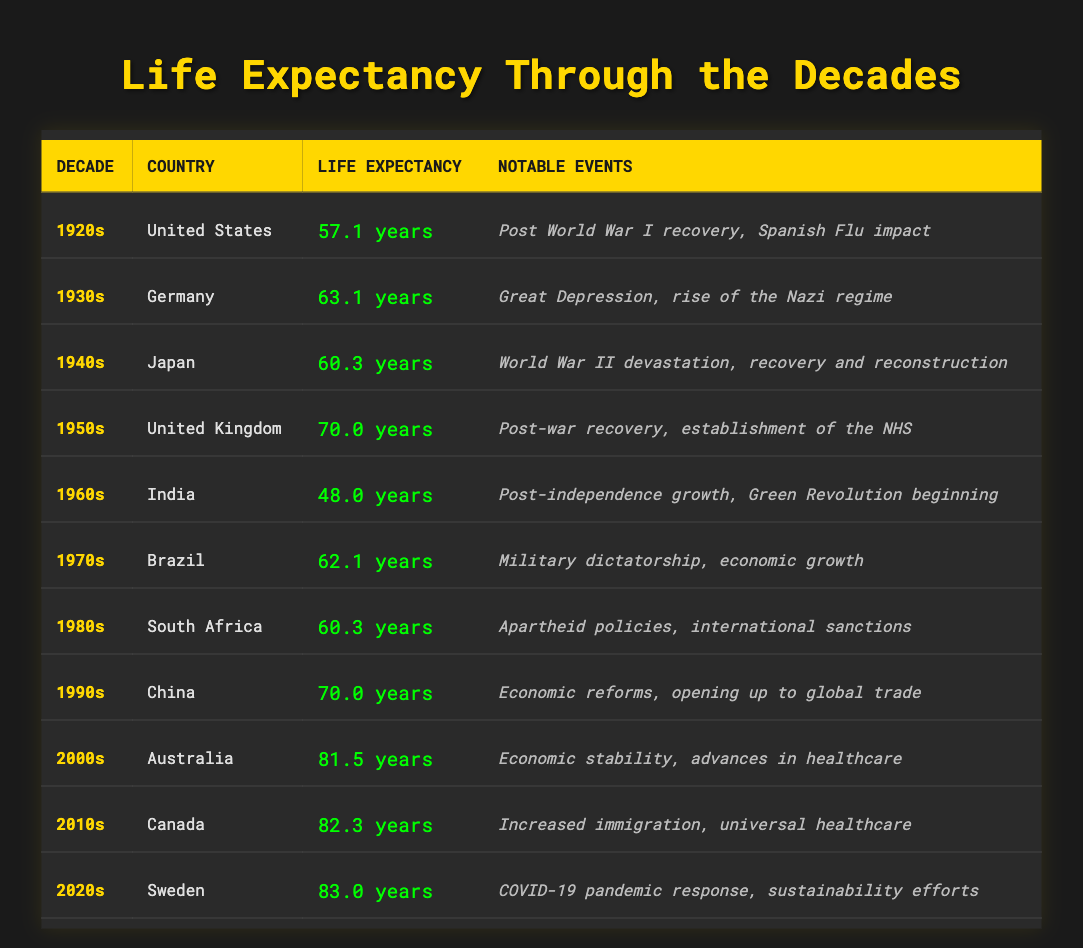What was the life expectancy in the 1950s for the United Kingdom? From the table, it shows that the life expectancy for the United Kingdom in the 1950s was 70.0 years.
Answer: 70.0 years Which country had the lowest life expectancy in the 1960s? By examining the data for the 1960s, India had the lowest life expectancy listed, which was 48.0 years.
Answer: India What is the difference in life expectancy between the 2000s (Australia) and the 1920s (United States)? The life expectancy in the 2000s for Australia was 81.5 years, and in the 1920s for the United States, it was 57.1 years. The difference is 81.5 - 57.1 = 24.4 years.
Answer: 24.4 years Did Germany's life expectancy in the 1930s exceed 60 years? The table shows that Germany's life expectancy in the 1930s was 63.1 years, which indeed exceeds 60 years.
Answer: Yes What was the average life expectancy of the countries presented in the 1990s and 2000s? The life expectancy for China in the 1990s was 70.0 years and for Australia in the 2000s, it was 81.5 years. To find the average, we sum the two values: 70.0 + 81.5 = 151.5, then divide by 2. The average is 151.5 / 2 = 75.75 years.
Answer: 75.75 years Which decade had the highest life expectancy, and what was the value? Scanning through the entire table, the highest life expectancy is noted in the 2020s for Sweden at 83.0 years.
Answer: 83.0 years Was there a significant increase in life expectancy from the 1980s (South Africa) to the 1990s (China)? The life expectancy in the 1980s for South Africa was 60.3 years and in the 1990s for China, it was 70.0 years. The increase is 70.0 - 60.3 = 9.7 years, indicating a significant increase.
Answer: Yes What notable event occurred during the 1940s in Japan? According to the table, the notable event during the 1940s in Japan was the devastation of World War II, followed by recovery and reconstruction.
Answer: World War II devastation How many decades had a life expectancy below 60 years? Looking at the table for decades with a life expectancy below 60 years, we find that the 1920s (57.1 years) and the 1960s (48.0 years) fit this criterion. Therefore, there are two decades with life expectancy below 60 years.
Answer: 2 decades 